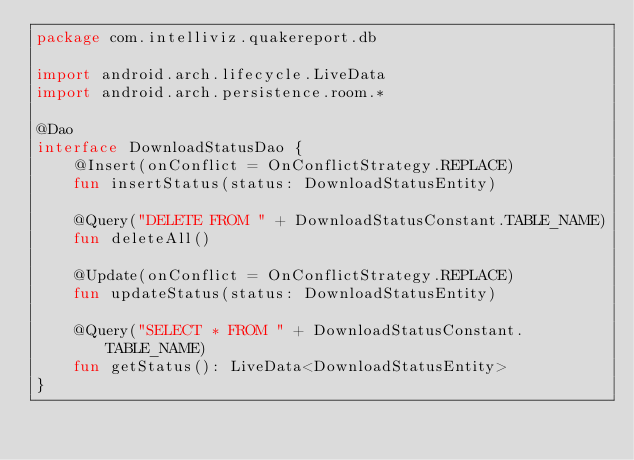<code> <loc_0><loc_0><loc_500><loc_500><_Kotlin_>package com.intelliviz.quakereport.db

import android.arch.lifecycle.LiveData
import android.arch.persistence.room.*

@Dao
interface DownloadStatusDao {
    @Insert(onConflict = OnConflictStrategy.REPLACE)
    fun insertStatus(status: DownloadStatusEntity)

    @Query("DELETE FROM " + DownloadStatusConstant.TABLE_NAME)
    fun deleteAll()

    @Update(onConflict = OnConflictStrategy.REPLACE)
    fun updateStatus(status: DownloadStatusEntity)

    @Query("SELECT * FROM " + DownloadStatusConstant.TABLE_NAME)
    fun getStatus(): LiveData<DownloadStatusEntity>
}</code> 